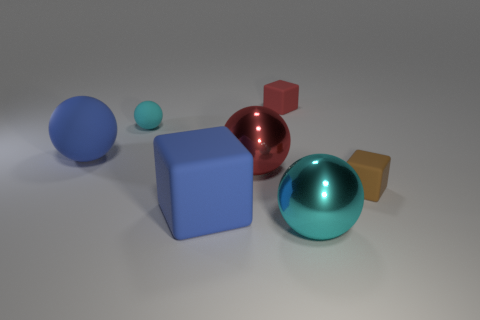Add 1 small red matte spheres. How many objects exist? 8 Subtract all spheres. How many objects are left? 3 Subtract 0 gray cylinders. How many objects are left? 7 Subtract all tiny balls. Subtract all brown things. How many objects are left? 5 Add 1 tiny cyan rubber objects. How many tiny cyan rubber objects are left? 2 Add 5 cubes. How many cubes exist? 8 